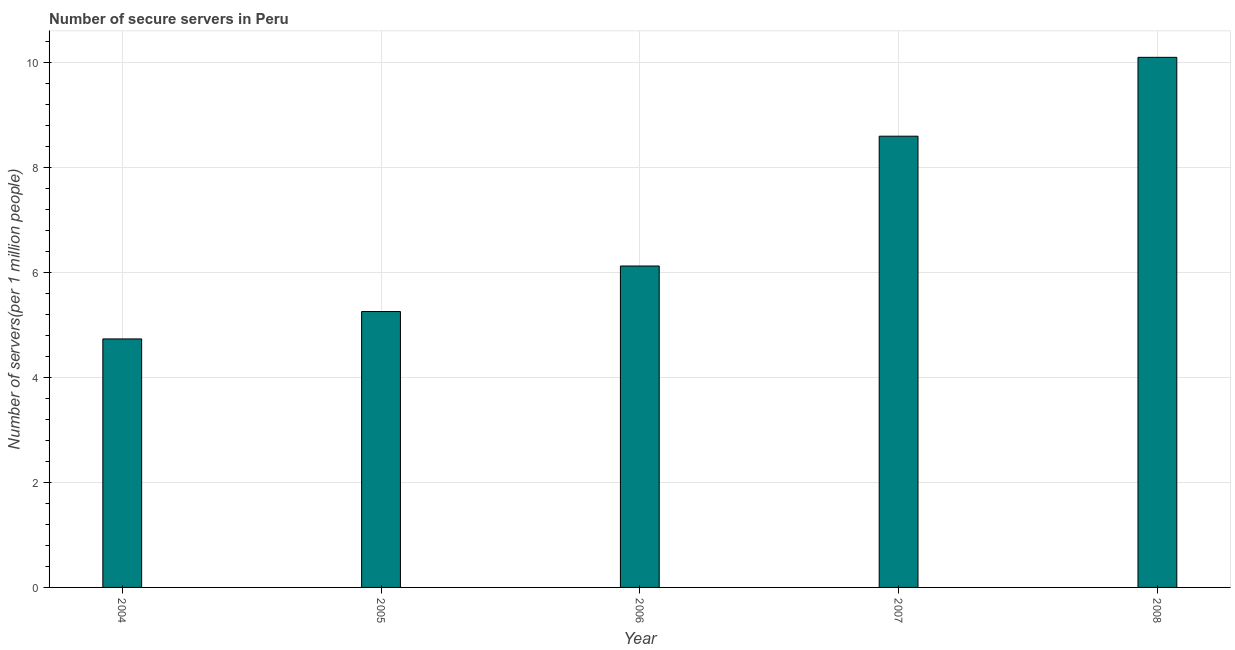Does the graph contain any zero values?
Offer a very short reply. No. Does the graph contain grids?
Provide a succinct answer. Yes. What is the title of the graph?
Keep it short and to the point. Number of secure servers in Peru. What is the label or title of the Y-axis?
Provide a succinct answer. Number of servers(per 1 million people). What is the number of secure internet servers in 2005?
Give a very brief answer. 5.25. Across all years, what is the maximum number of secure internet servers?
Provide a short and direct response. 10.09. Across all years, what is the minimum number of secure internet servers?
Your answer should be compact. 4.73. In which year was the number of secure internet servers maximum?
Ensure brevity in your answer.  2008. In which year was the number of secure internet servers minimum?
Offer a very short reply. 2004. What is the sum of the number of secure internet servers?
Your response must be concise. 34.78. What is the difference between the number of secure internet servers in 2004 and 2006?
Give a very brief answer. -1.39. What is the average number of secure internet servers per year?
Give a very brief answer. 6.96. What is the median number of secure internet servers?
Provide a succinct answer. 6.12. Do a majority of the years between 2007 and 2004 (inclusive) have number of secure internet servers greater than 0.8 ?
Ensure brevity in your answer.  Yes. What is the ratio of the number of secure internet servers in 2005 to that in 2007?
Give a very brief answer. 0.61. Is the number of secure internet servers in 2005 less than that in 2007?
Make the answer very short. Yes. Is the difference between the number of secure internet servers in 2006 and 2007 greater than the difference between any two years?
Your answer should be very brief. No. What is the difference between the highest and the second highest number of secure internet servers?
Keep it short and to the point. 1.5. What is the difference between the highest and the lowest number of secure internet servers?
Offer a terse response. 5.36. In how many years, is the number of secure internet servers greater than the average number of secure internet servers taken over all years?
Provide a short and direct response. 2. Are all the bars in the graph horizontal?
Your answer should be compact. No. How many years are there in the graph?
Make the answer very short. 5. What is the difference between two consecutive major ticks on the Y-axis?
Your answer should be compact. 2. Are the values on the major ticks of Y-axis written in scientific E-notation?
Your answer should be compact. No. What is the Number of servers(per 1 million people) of 2004?
Keep it short and to the point. 4.73. What is the Number of servers(per 1 million people) of 2005?
Your answer should be compact. 5.25. What is the Number of servers(per 1 million people) of 2006?
Make the answer very short. 6.12. What is the Number of servers(per 1 million people) of 2007?
Keep it short and to the point. 8.59. What is the Number of servers(per 1 million people) in 2008?
Your answer should be compact. 10.09. What is the difference between the Number of servers(per 1 million people) in 2004 and 2005?
Ensure brevity in your answer.  -0.52. What is the difference between the Number of servers(per 1 million people) in 2004 and 2006?
Your answer should be very brief. -1.39. What is the difference between the Number of servers(per 1 million people) in 2004 and 2007?
Your answer should be very brief. -3.86. What is the difference between the Number of servers(per 1 million people) in 2004 and 2008?
Provide a succinct answer. -5.36. What is the difference between the Number of servers(per 1 million people) in 2005 and 2006?
Ensure brevity in your answer.  -0.87. What is the difference between the Number of servers(per 1 million people) in 2005 and 2007?
Provide a short and direct response. -3.34. What is the difference between the Number of servers(per 1 million people) in 2005 and 2008?
Offer a very short reply. -4.84. What is the difference between the Number of servers(per 1 million people) in 2006 and 2007?
Keep it short and to the point. -2.47. What is the difference between the Number of servers(per 1 million people) in 2006 and 2008?
Provide a short and direct response. -3.97. What is the difference between the Number of servers(per 1 million people) in 2007 and 2008?
Your response must be concise. -1.5. What is the ratio of the Number of servers(per 1 million people) in 2004 to that in 2005?
Your answer should be very brief. 0.9. What is the ratio of the Number of servers(per 1 million people) in 2004 to that in 2006?
Offer a very short reply. 0.77. What is the ratio of the Number of servers(per 1 million people) in 2004 to that in 2007?
Keep it short and to the point. 0.55. What is the ratio of the Number of servers(per 1 million people) in 2004 to that in 2008?
Offer a terse response. 0.47. What is the ratio of the Number of servers(per 1 million people) in 2005 to that in 2006?
Your answer should be very brief. 0.86. What is the ratio of the Number of servers(per 1 million people) in 2005 to that in 2007?
Provide a succinct answer. 0.61. What is the ratio of the Number of servers(per 1 million people) in 2005 to that in 2008?
Provide a short and direct response. 0.52. What is the ratio of the Number of servers(per 1 million people) in 2006 to that in 2007?
Give a very brief answer. 0.71. What is the ratio of the Number of servers(per 1 million people) in 2006 to that in 2008?
Provide a succinct answer. 0.61. What is the ratio of the Number of servers(per 1 million people) in 2007 to that in 2008?
Provide a short and direct response. 0.85. 